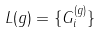Convert formula to latex. <formula><loc_0><loc_0><loc_500><loc_500>L ( g ) = \{ G _ { i } ^ { ( g ) } \}</formula> 